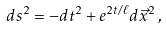<formula> <loc_0><loc_0><loc_500><loc_500>d s ^ { 2 } = - d t ^ { 2 } + e ^ { 2 t / \ell } d \vec { x } ^ { 2 } \, ,</formula> 